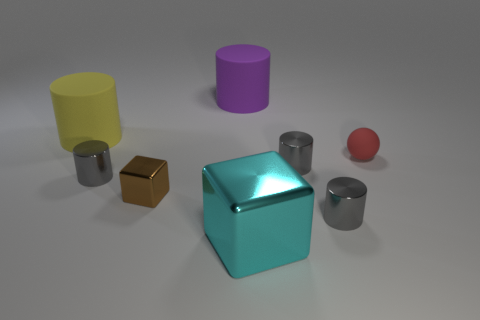Subtract all gray cylinders. How many were subtracted if there are1gray cylinders left? 2 Subtract all yellow cylinders. How many cylinders are left? 4 Add 2 cyan shiny cubes. How many objects exist? 10 Subtract 1 spheres. How many spheres are left? 0 Subtract all gray cylinders. How many cylinders are left? 2 Subtract all cubes. How many objects are left? 6 Subtract all cyan cylinders. How many gray blocks are left? 0 Subtract all rubber balls. Subtract all metal blocks. How many objects are left? 5 Add 7 small matte things. How many small matte things are left? 8 Add 1 cyan matte things. How many cyan matte things exist? 1 